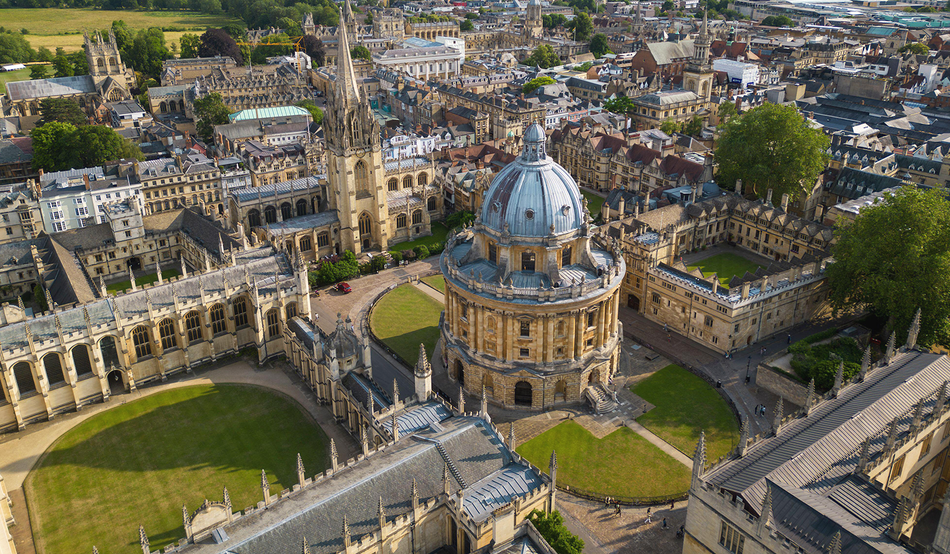What do you see happening in this image? The image offers a stunning aerial perspective of Oxford University, one of the most historic and prestigious educational institutions in the world. At the center is the iconic Radcliffe Camera, a magnificent circular library topped with an ornate dome. This architectural gem, crafted from light-colored stone, stands out against the intricate backdrop of surrounding buildings. The campus' buildings, adorned with spires and detailed facades, radiate historical significance and scholarly tradition. Neatly arranged courtyards, filled with lush greenery, contrast beautifully with the stone structures. This high-angle shot captures the harmonious layout and grand design of the university, embodying centuries of academic excellence and heritage. 